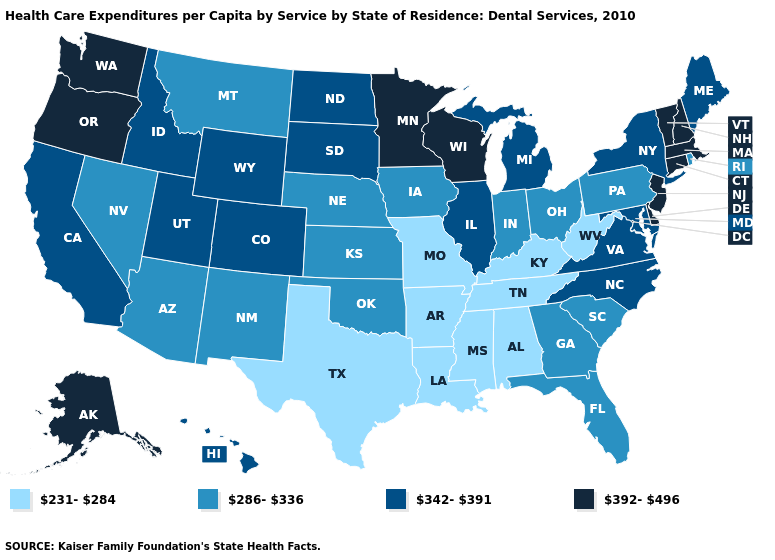Does the first symbol in the legend represent the smallest category?
Concise answer only. Yes. Is the legend a continuous bar?
Answer briefly. No. Name the states that have a value in the range 286-336?
Quick response, please. Arizona, Florida, Georgia, Indiana, Iowa, Kansas, Montana, Nebraska, Nevada, New Mexico, Ohio, Oklahoma, Pennsylvania, Rhode Island, South Carolina. Which states hav the highest value in the West?
Short answer required. Alaska, Oregon, Washington. Name the states that have a value in the range 231-284?
Be succinct. Alabama, Arkansas, Kentucky, Louisiana, Mississippi, Missouri, Tennessee, Texas, West Virginia. Does Arkansas have the highest value in the South?
Give a very brief answer. No. Does Iowa have the lowest value in the MidWest?
Be succinct. No. What is the value of Alabama?
Give a very brief answer. 231-284. Name the states that have a value in the range 342-391?
Keep it brief. California, Colorado, Hawaii, Idaho, Illinois, Maine, Maryland, Michigan, New York, North Carolina, North Dakota, South Dakota, Utah, Virginia, Wyoming. Name the states that have a value in the range 392-496?
Short answer required. Alaska, Connecticut, Delaware, Massachusetts, Minnesota, New Hampshire, New Jersey, Oregon, Vermont, Washington, Wisconsin. What is the highest value in the USA?
Write a very short answer. 392-496. Name the states that have a value in the range 286-336?
Write a very short answer. Arizona, Florida, Georgia, Indiana, Iowa, Kansas, Montana, Nebraska, Nevada, New Mexico, Ohio, Oklahoma, Pennsylvania, Rhode Island, South Carolina. Name the states that have a value in the range 231-284?
Keep it brief. Alabama, Arkansas, Kentucky, Louisiana, Mississippi, Missouri, Tennessee, Texas, West Virginia. Among the states that border Wisconsin , does Iowa have the lowest value?
Write a very short answer. Yes. Is the legend a continuous bar?
Answer briefly. No. 